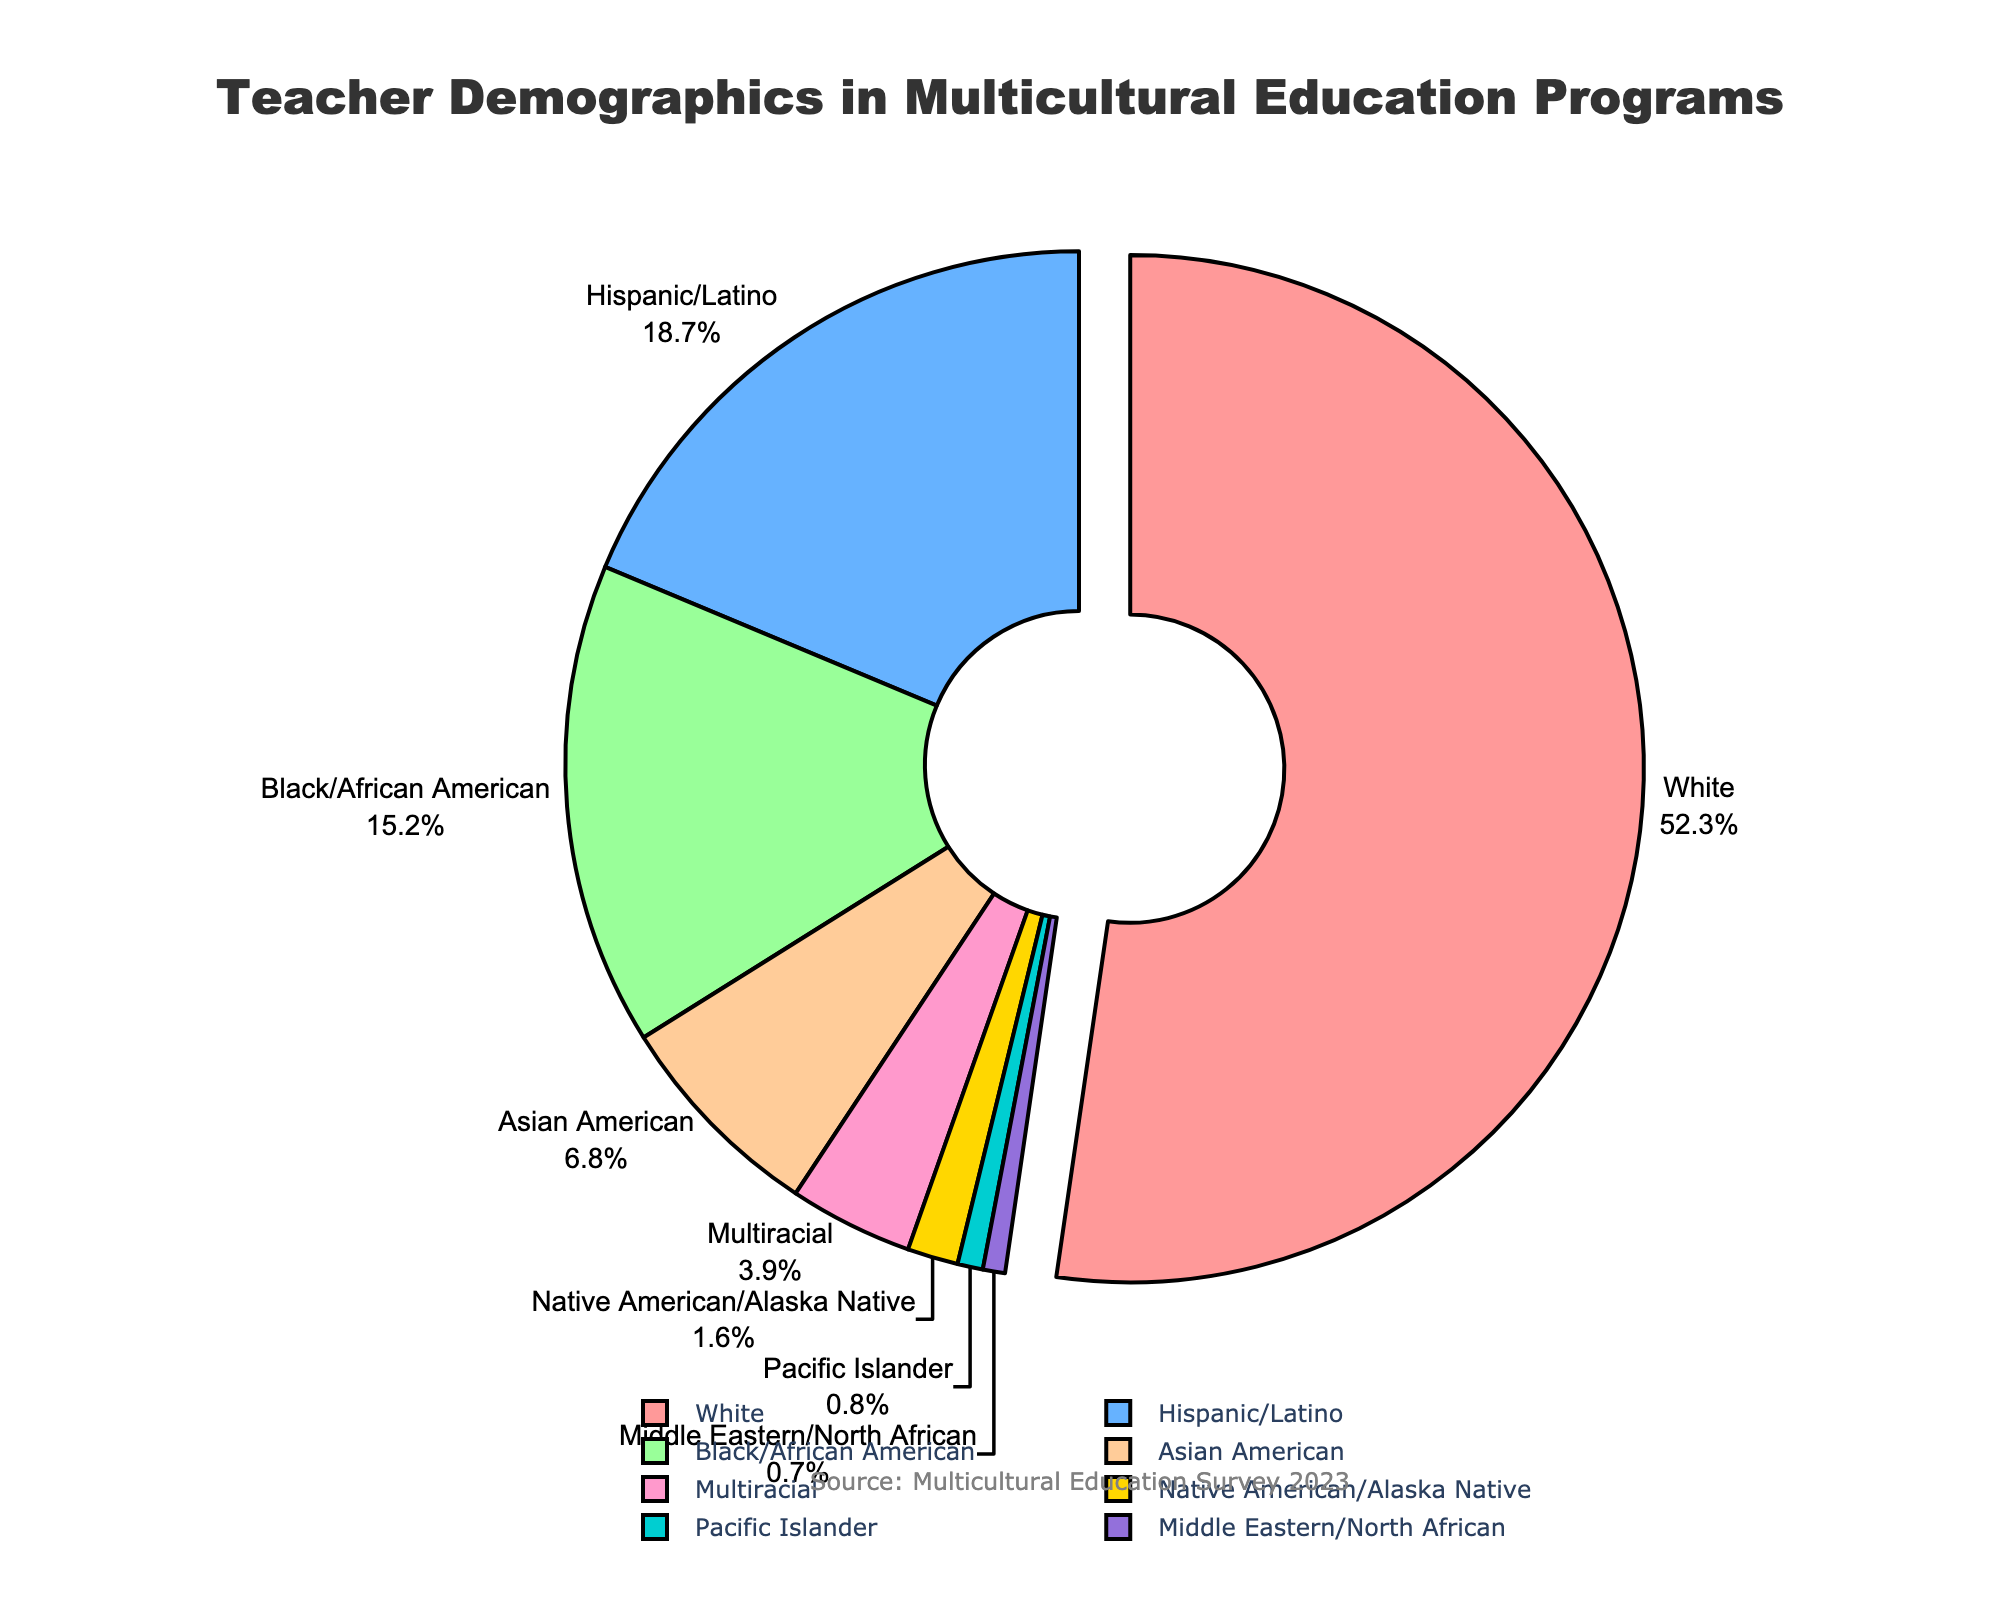What's the largest racial/ethnic group among teachers in multicultural education programs according to the pie chart? By looking at the pie chart, the largest segment visually represents the racial/ethnic group with the highest percentage. In this case, it is the White group.
Answer: White What's the total percentage of teachers from Hispanic/Latino, Black/African American, and Asian American backgrounds? Sum the percentages for Hispanic/Latino (18.7%), Black/African American (15.2%), and Asian American (6.8%): 18.7 + 15.2 + 6.8 = 40.7
Answer: 40.7% Which racial/ethnic group comprises the smallest segment of the teacher demographics in the pie chart? The smallest segment is visually represented by the smallest slice in the pie chart. Here, it is the Middle Eastern/North African group with 0.7%.
Answer: Middle Eastern/North African How does the percentage of White teachers compare to the total percentage of all other groups combined? The percentage of White teachers is 52.3%. Subtract this from 100% to find the combined percentage of all other groups: 100 - 52.3 = 47.7. The percentage of White teachers is greater than the combined percentage of all other groups.
Answer: Greater Which groups together make up more than half of the teacher demographics in multicultural education programs? Look for groups whose combined percentage exceeds 50%. The White group alone contributes 52.3%, which is already more than half.
Answer: White What's the difference in percentage between Black/African American teachers and Asian American teachers? Subtract the percentage of Asian American teachers (6.8%) from that of Black/African American teachers (15.2%): 15.2 - 6.8 = 8.4
Answer: 8.4% If we combine the percentages of Native American/Alaska Native, Pacific Islander, and Middle Eastern/North African teachers, what proportion of the total does this group represent? Sum the percentages: Native American/Alaska Native (1.6%), Pacific Islander (0.8%), and Middle Eastern/North African (0.7%): 1.6 + 0.8 + 0.7 = 3.1
Answer: 3.1% Are Hispanic/Latino teachers more or less prevalent than Asian American teachers according to the pie chart? Compare the percentages: Hispanic/Latino with 18.7% and Asian American with 6.8%. Hispanic/Latino is more prevalent.
Answer: More prevalent What percentile rank does the Multiracial category occupy if we list the groups in descending order by their percentage? Rank the groups by percentage: White (52.3%), Hispanic/Latino (18.7%), Black/African American (15.2%), Asian American (6.8%), Multiracial (3.9%), Native American/Alaska Native (1.6%), Pacific Islander (0.8%), Middle Eastern/North African (0.7%). Multiracial occupies the 5th rank.
Answer: 5th 